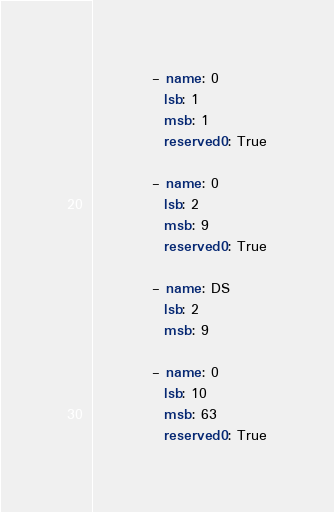<code> <loc_0><loc_0><loc_500><loc_500><_YAML_>
          - name: 0
            lsb: 1
            msb: 1
            reserved0: True

          - name: 0
            lsb: 2
            msb: 9
            reserved0: True

          - name: DS
            lsb: 2
            msb: 9

          - name: 0
            lsb: 10
            msb: 63
            reserved0: True
</code> 